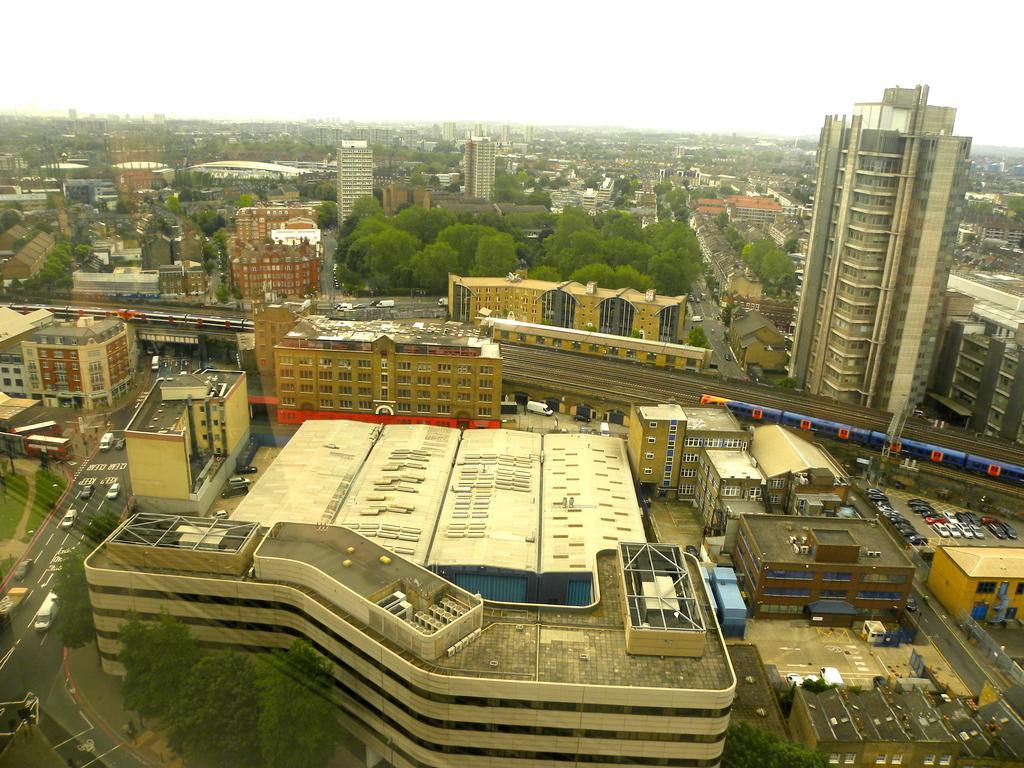In one or two sentences, can you explain what this image depicts? This is an aerial view. In this picture we can see the buildings, trees, road, some vehicles, train, railway track, sheds. At the top of the image we can see the sky. 